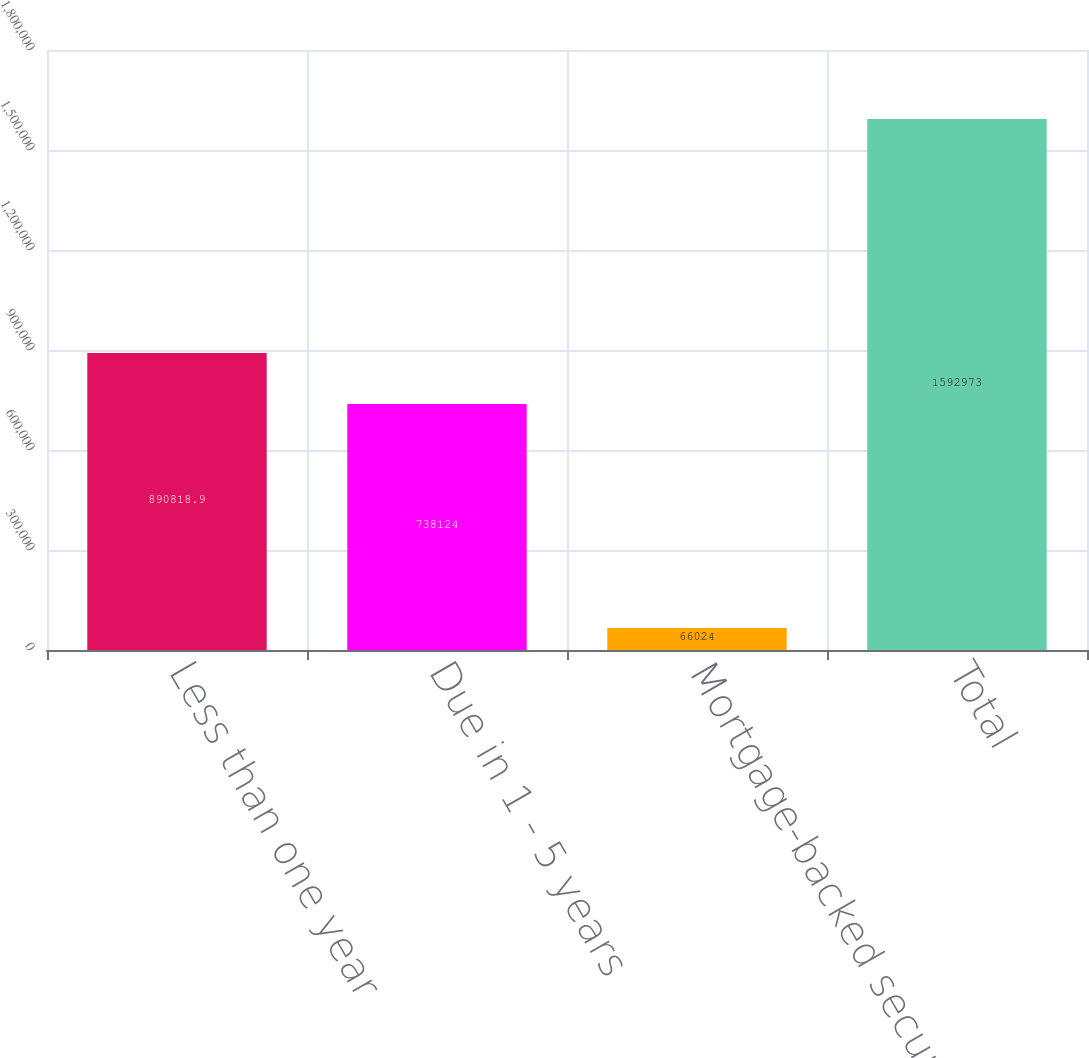Convert chart to OTSL. <chart><loc_0><loc_0><loc_500><loc_500><bar_chart><fcel>Less than one year<fcel>Due in 1 - 5 years<fcel>Mortgage-backed securities<fcel>Total<nl><fcel>890819<fcel>738124<fcel>66024<fcel>1.59297e+06<nl></chart> 